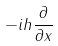<formula> <loc_0><loc_0><loc_500><loc_500>- i h \frac { \partial } { \partial x }</formula> 